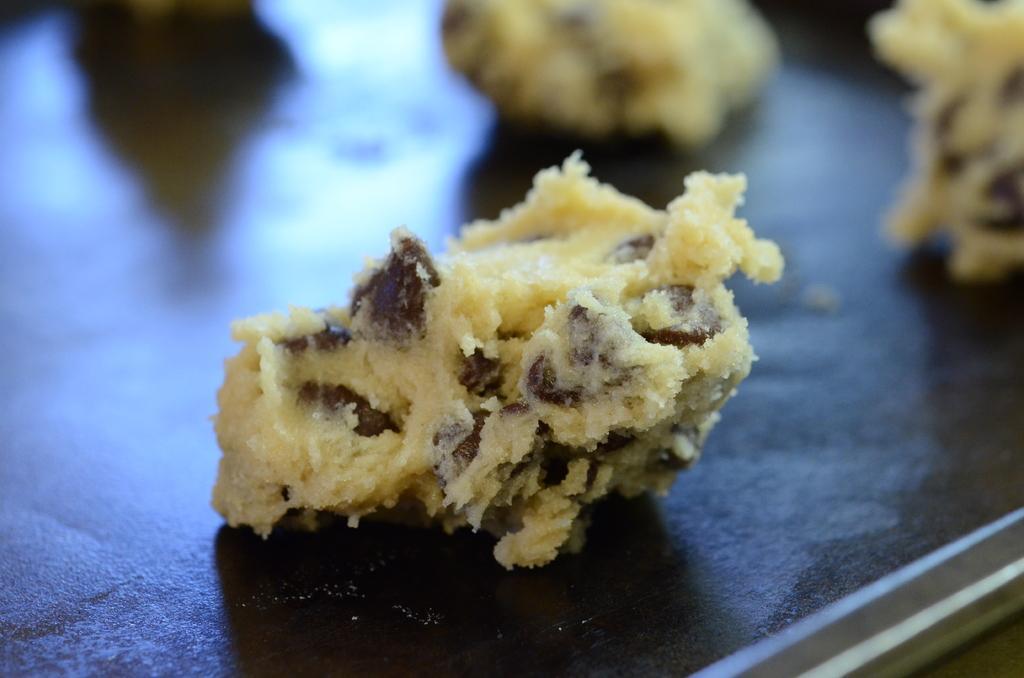How would you summarize this image in a sentence or two? In this picture we can see some food on a black surface. 